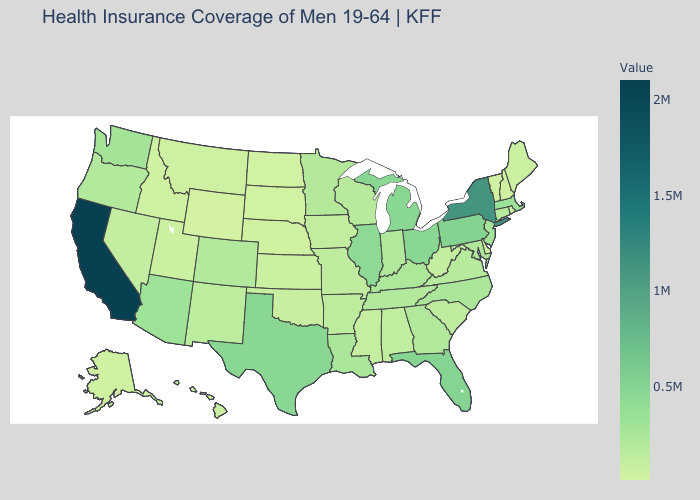Does Georgia have the highest value in the USA?
Quick response, please. No. Does the map have missing data?
Quick response, please. No. Does Delaware have a higher value than New York?
Answer briefly. No. Which states hav the highest value in the Northeast?
Be succinct. New York. Does Massachusetts have the highest value in the USA?
Be succinct. No. Which states have the highest value in the USA?
Short answer required. California. Among the states that border Pennsylvania , does New York have the lowest value?
Short answer required. No. 